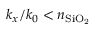<formula> <loc_0><loc_0><loc_500><loc_500>k _ { x } / k _ { 0 } < n _ { S i O _ { 2 } }</formula> 